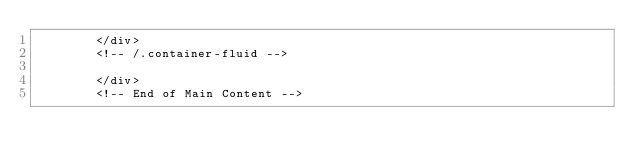<code> <loc_0><loc_0><loc_500><loc_500><_PHP_>        </div>
        <!-- /.container-fluid -->

        </div>
        <!-- End of Main Content --></code> 